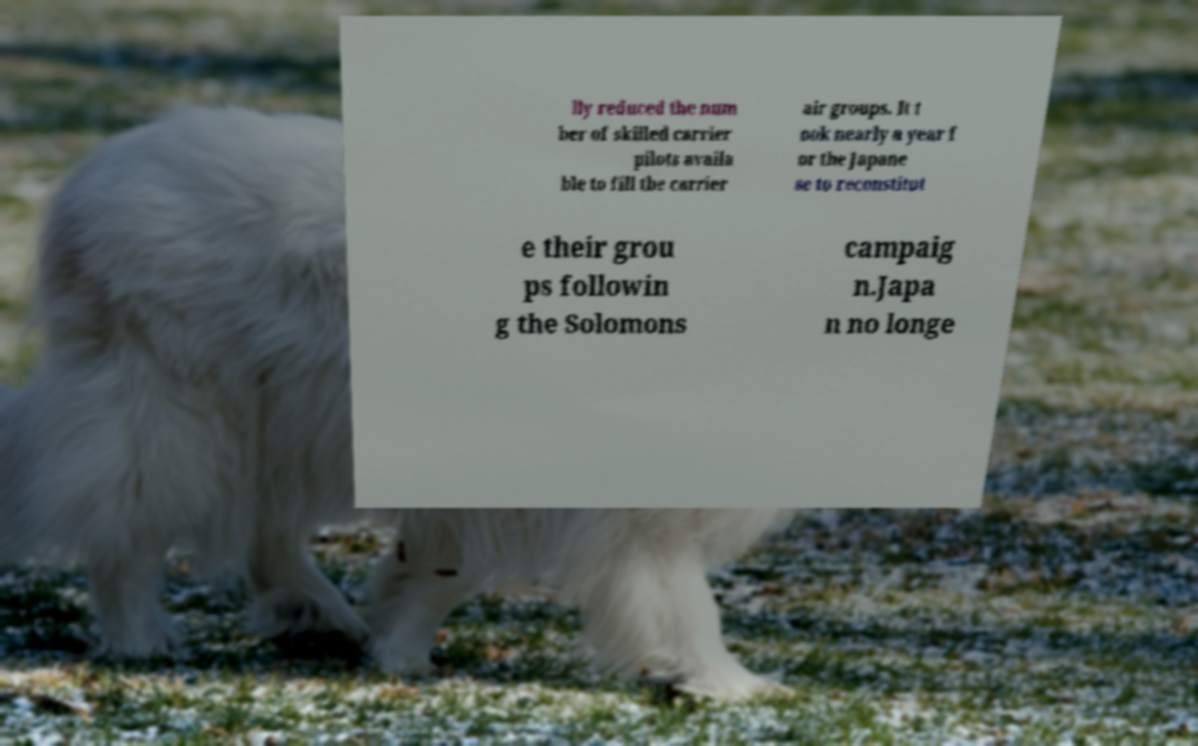Can you accurately transcribe the text from the provided image for me? lly reduced the num ber of skilled carrier pilots availa ble to fill the carrier air groups. It t ook nearly a year f or the Japane se to reconstitut e their grou ps followin g the Solomons campaig n.Japa n no longe 